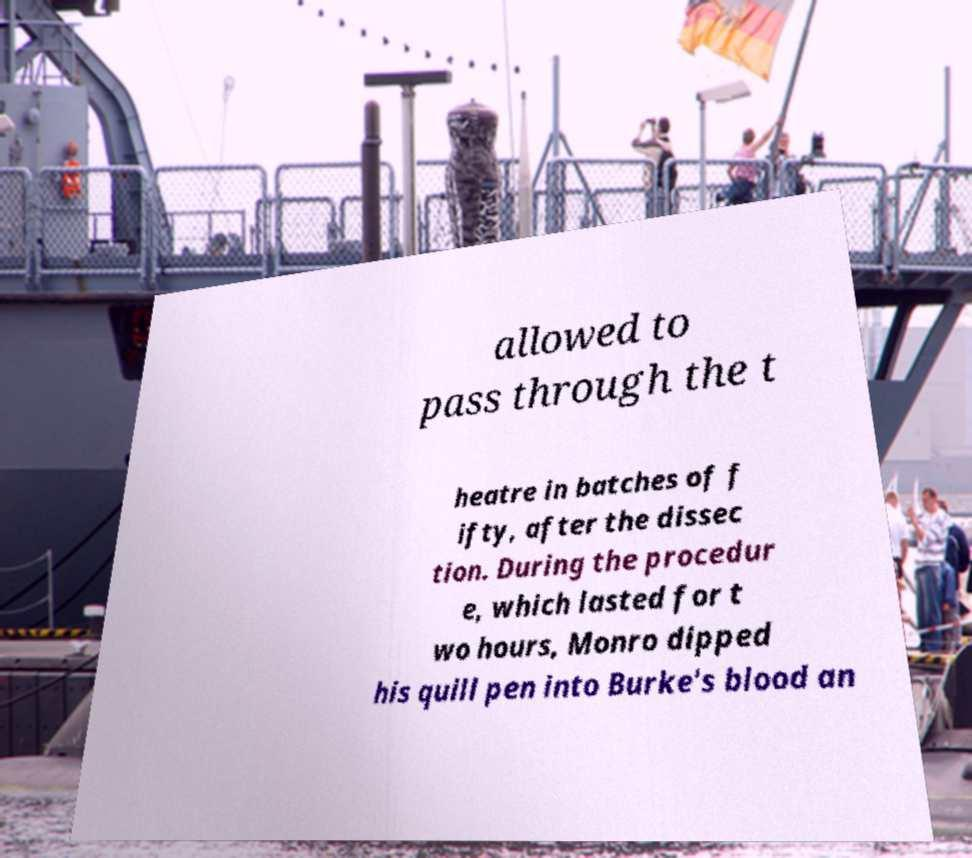For documentation purposes, I need the text within this image transcribed. Could you provide that? allowed to pass through the t heatre in batches of f ifty, after the dissec tion. During the procedur e, which lasted for t wo hours, Monro dipped his quill pen into Burke's blood an 